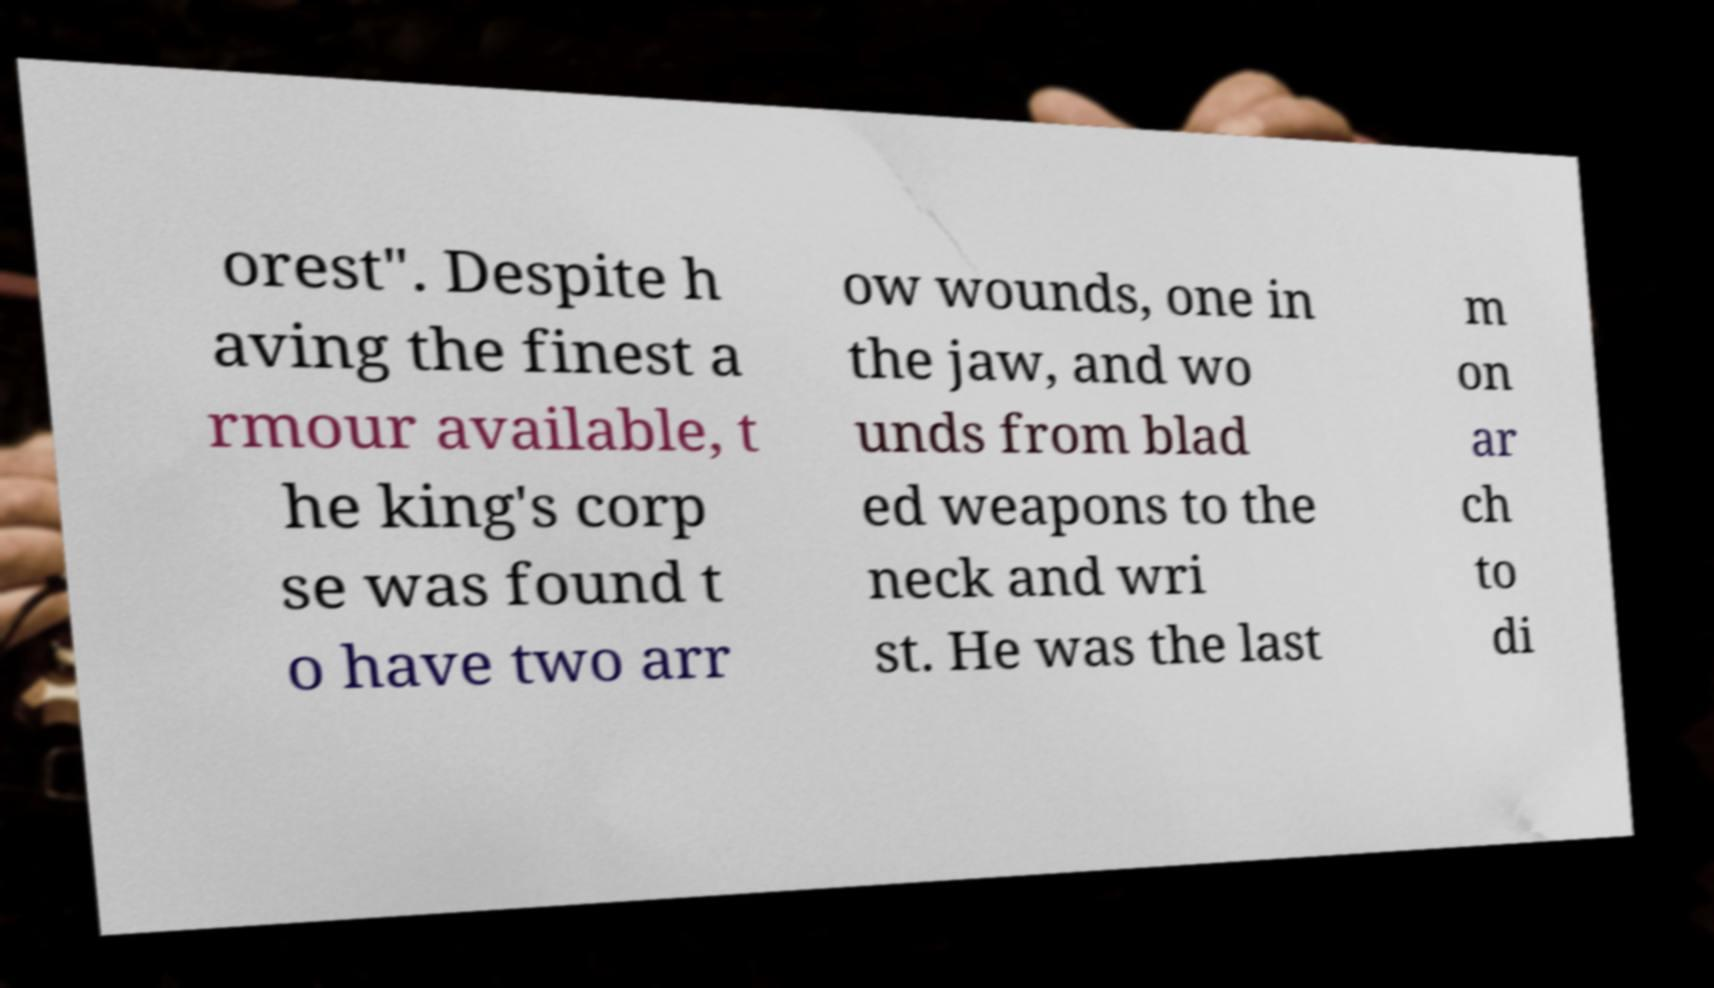Can you accurately transcribe the text from the provided image for me? orest". Despite h aving the finest a rmour available, t he king's corp se was found t o have two arr ow wounds, one in the jaw, and wo unds from blad ed weapons to the neck and wri st. He was the last m on ar ch to di 